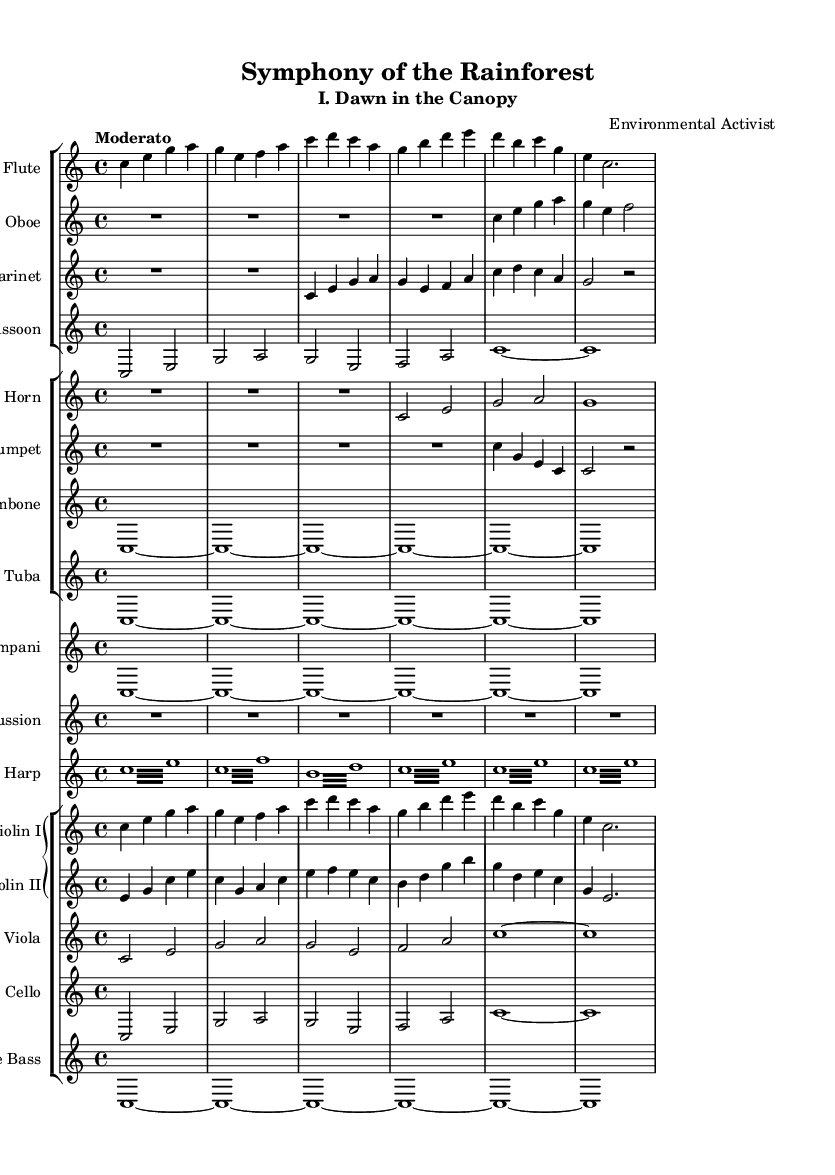what is the key signature of this music? The key signature is C major, which is indicated at the beginning of the score with no sharps or flats shown.
Answer: C major what is the time signature of this symphony? The time signature is 4/4, denoted at the beginning of the score, indicating four beats per measure.
Answer: 4/4 what is the tempo marking for this piece? The tempo marking "Moderato" is provided at the beginning, indicating a moderately paced performance.
Answer: Moderato how many different instruments are used in this symphony? By reviewing the score, there are a total of 15 instruments listed across various staff groups, including woodwinds, brass, strings, and percussion.
Answer: 15 which instrument plays the first melodic line? The flute plays the first melodic line as it is positioned at the top of the first staff group and has the initial notes in the score.
Answer: Flute how many measures are there in the first section? By examining the flute part, the first section consists of six measures, as seen from the notation that follows the initial setup.
Answer: 6 what role does the timpani play in this symphony? The timpani part is written as a sustained note (C) throughout, providing a foundational and harmonic support to the piece, typical for its role in symphonic music.
Answer: Harmonic support 